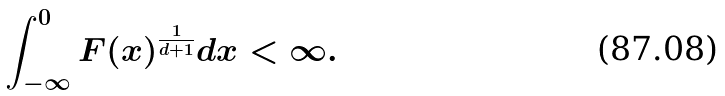Convert formula to latex. <formula><loc_0><loc_0><loc_500><loc_500>\int _ { - \infty } ^ { 0 } F ( x ) ^ { \frac { 1 } { d + 1 } } d x < \infty .</formula> 